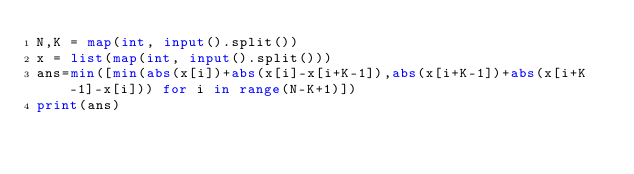<code> <loc_0><loc_0><loc_500><loc_500><_Python_>N,K = map(int, input().split())
x = list(map(int, input().split()))
ans=min([min(abs(x[i])+abs(x[i]-x[i+K-1]),abs(x[i+K-1])+abs(x[i+K-1]-x[i])) for i in range(N-K+1)])
print(ans)</code> 